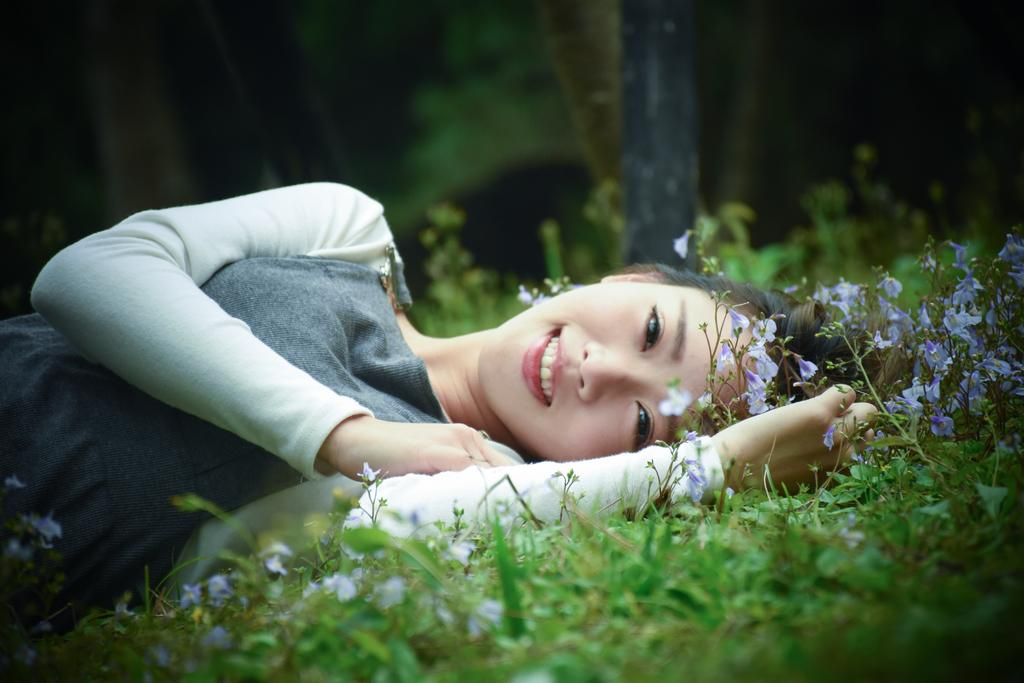Who is the main subject in the image? There is a woman in the image. What is the woman doing in the image? The woman is lying on the ground. What is the woman's facial expression in the image? The woman is smiling. What type of natural environment is visible in the image? There is grass and flowers visible in the image. How would you describe the background of the image? The background of the image is blurred. What type of nation is depicted in the image? There is no nation depicted in the image; it features a woman lying on the ground with a smile on her face, surrounded by grass and flowers. How much money is the woman holding in the image? There is no money visible in the image; it only shows a woman lying on the ground with a smile on her face, surrounded by grass and flowers. 